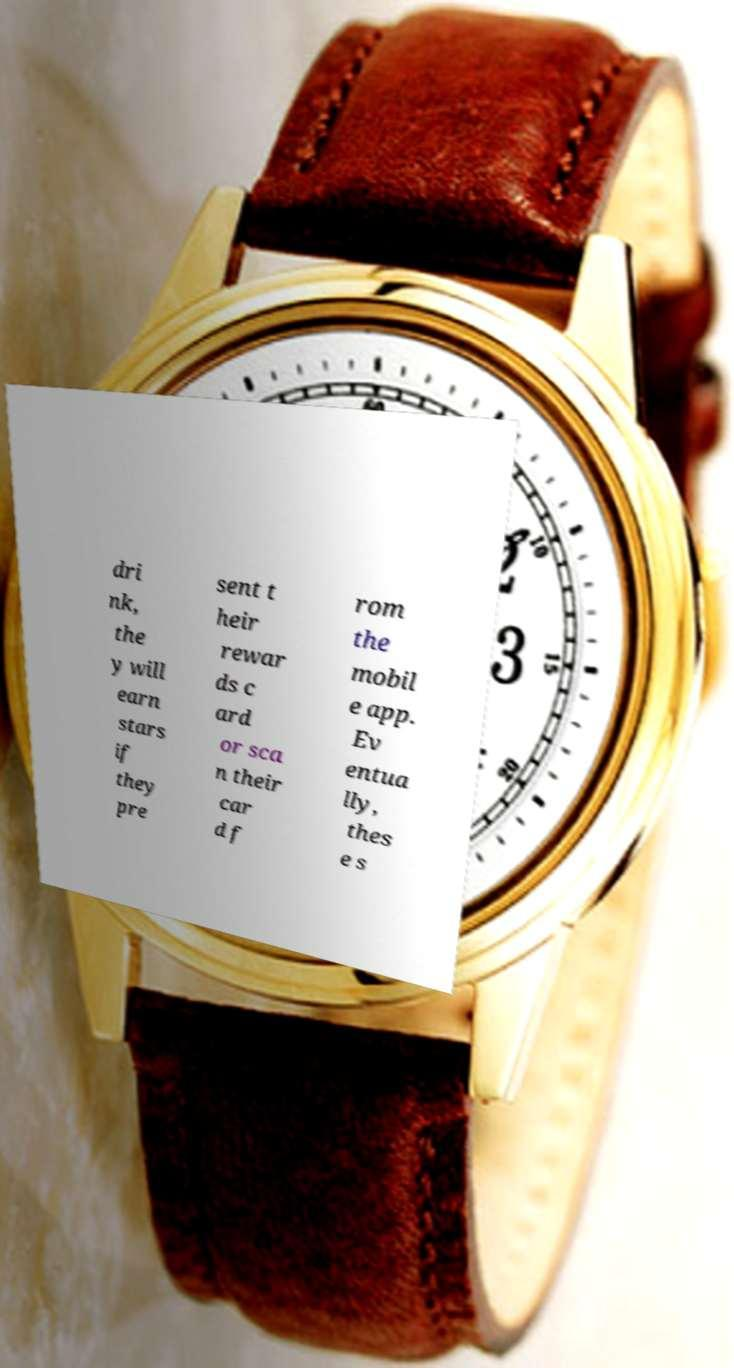Please identify and transcribe the text found in this image. dri nk, the y will earn stars if they pre sent t heir rewar ds c ard or sca n their car d f rom the mobil e app. Ev entua lly, thes e s 